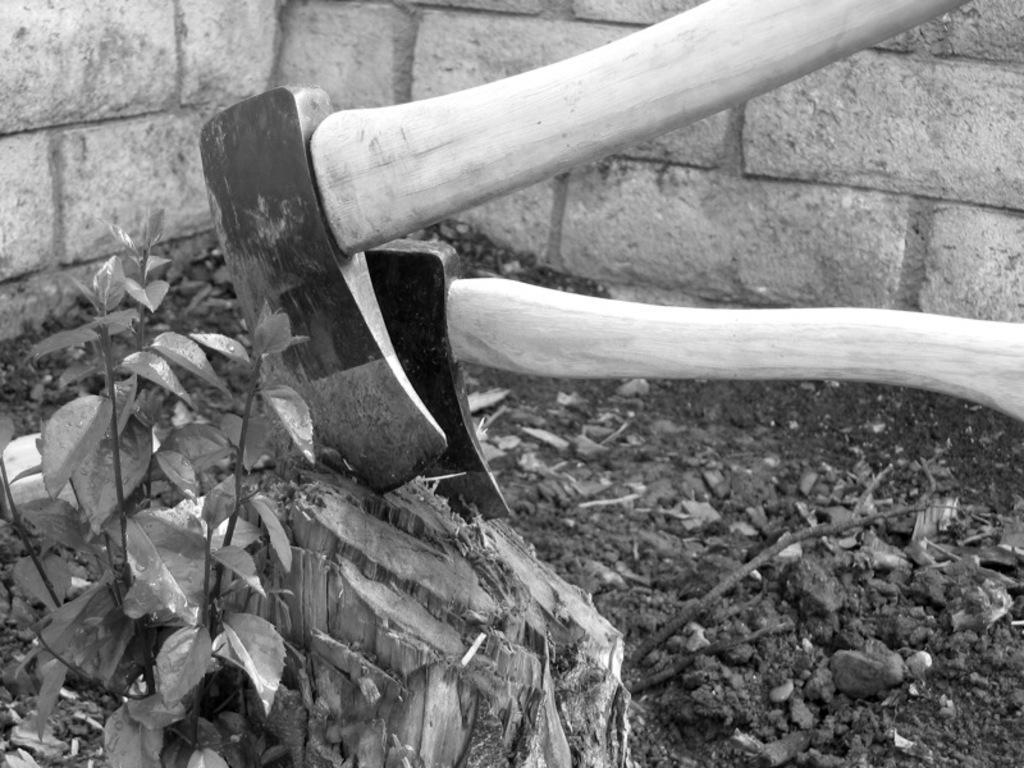Could you give a brief overview of what you see in this image? In this picture we can see axes, here we can see a wooden object, plant, sticks on the ground and we can see a wall in the background. 